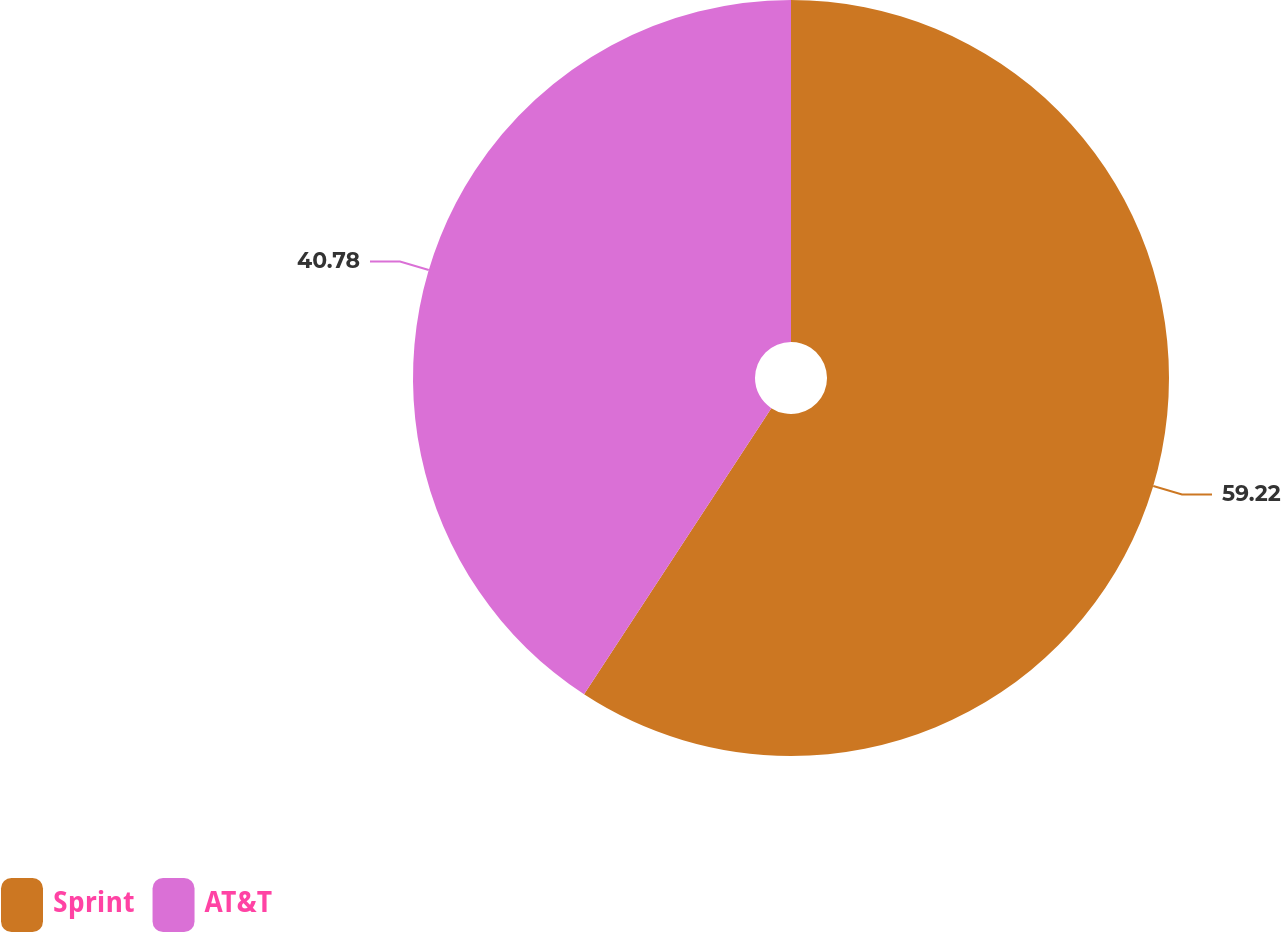<chart> <loc_0><loc_0><loc_500><loc_500><pie_chart><fcel>Sprint<fcel>AT&T<nl><fcel>59.22%<fcel>40.78%<nl></chart> 